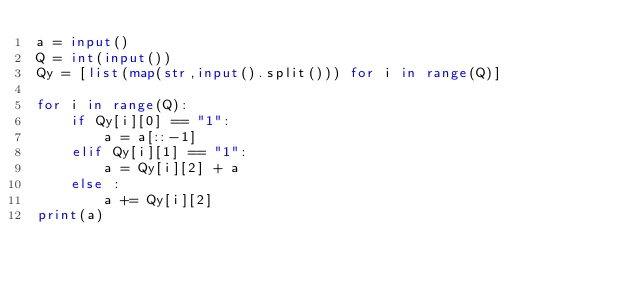Convert code to text. <code><loc_0><loc_0><loc_500><loc_500><_Python_>a = input()
Q = int(input())
Qy = [list(map(str,input().split())) for i in range(Q)]

for i in range(Q):
    if Qy[i][0] == "1":
        a = a[::-1]
    elif Qy[i][1] == "1":
        a = Qy[i][2] + a
    else :
        a += Qy[i][2]
print(a)</code> 